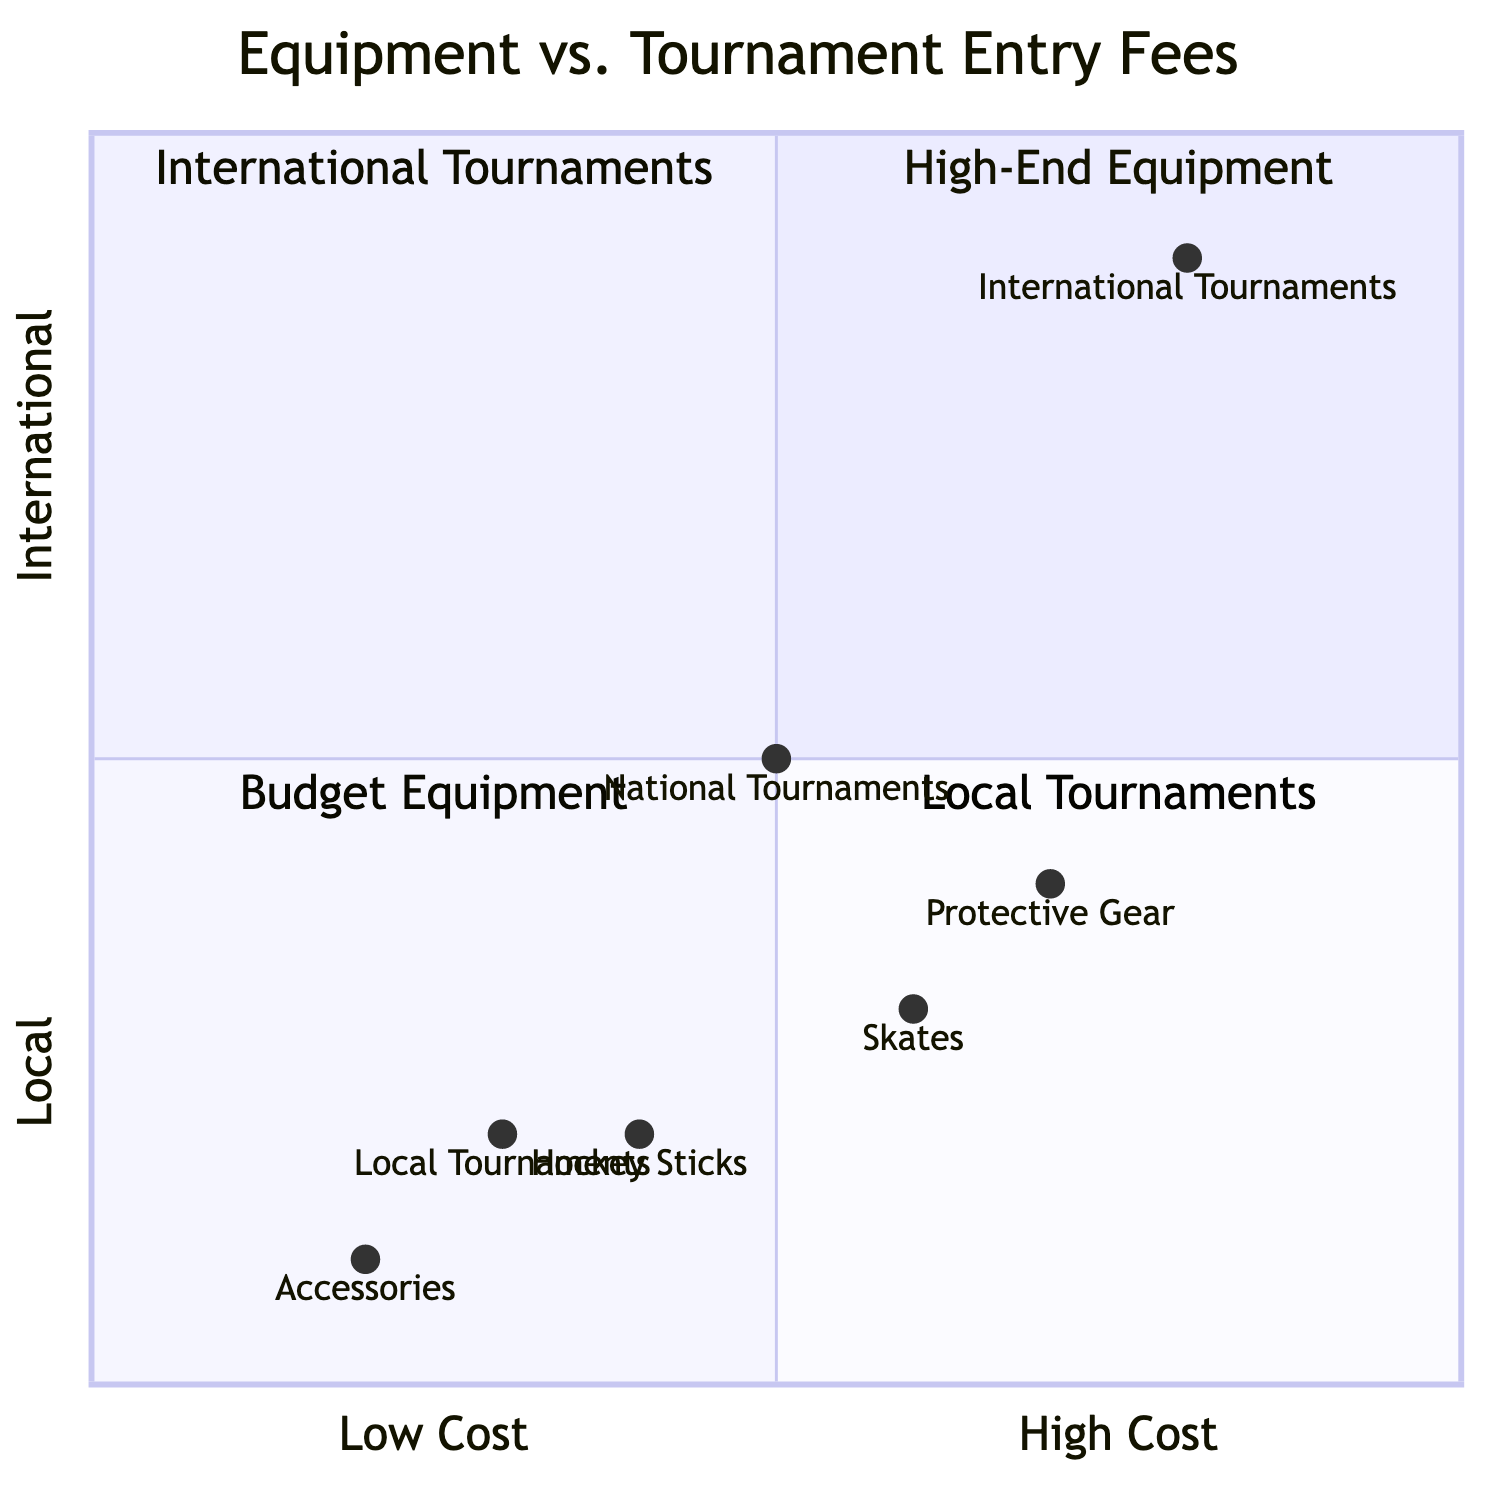What is the most expensive item in the Equipment category? The Protective Gear falls in the range of $200 - $800, which is higher than the ranges of other equipment items. The Skates range between $100 - $700 and the Hockey Sticks range from $50 - $300. Therefore, Protective Gear is the most expensive.
Answer: Protective Gear Which quadrant contains Local Tournaments? According to the layout of the quadrant chart, Local Tournaments are positioned in Quadrant 4.
Answer: Quadrant 4 How many items are classified as Budget Equipment? The Budget Equipment, categorized in Quadrant 3, includes Accessories, Hockey Sticks, and Skates, which are three items in total.
Answer: 3 What is the average cost range for International Tournaments? According to the chart's details, International Tournaments have an average cost range of $700 - $2000.
Answer: $700 - $2000 Which Equipment item lies closest to the International Tournaments in the chart? The Protective Gear, located at coordinates [0.7, 0.4], is the Equipment item that is closest to the International Tournaments located at [0.8, 0.9].
Answer: Protective Gear Which category has the highest placement on the y-axis? The International Tournaments have the highest placement on the y-axis at 0.9, making them the category that reaches the highest point.
Answer: International Tournaments How does the cost of Local Tournaments compare to the cost of Accessories? Local Tournaments are located at [0.3, 0.2], in the quadrant designated for local and lower cost. The Accessories are at [0.2, 0.1], both of which indicate lower costs, but Local Tournaments are still higher-cost than Accessories.
Answer: Local Tournaments are higher-cost What quadrant does Skates occupy? The Skates are located in Quadrant 1, which represents High-End Equipment.
Answer: Quadrant 1 What is the y-axis value for National Tournaments? The National Tournaments have a y-axis value of 0.5, positioning them in between the Local and International levels.
Answer: 0.5 